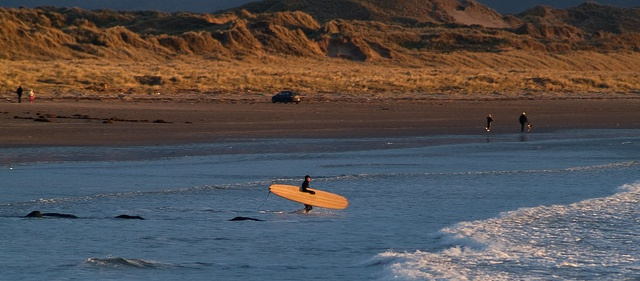Describe the objects in this image and their specific colors. I can see surfboard in darkblue, orange, and brown tones, car in darkblue, black, maroon, and gray tones, people in darkblue, black, maroon, and gray tones, people in darkblue, black, maroon, olive, and gray tones, and people in darkblue, black, maroon, and brown tones in this image. 